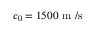Convert formula to latex. <formula><loc_0><loc_0><loc_500><loc_500>c _ { 0 } = 1 5 0 0 m / s</formula> 